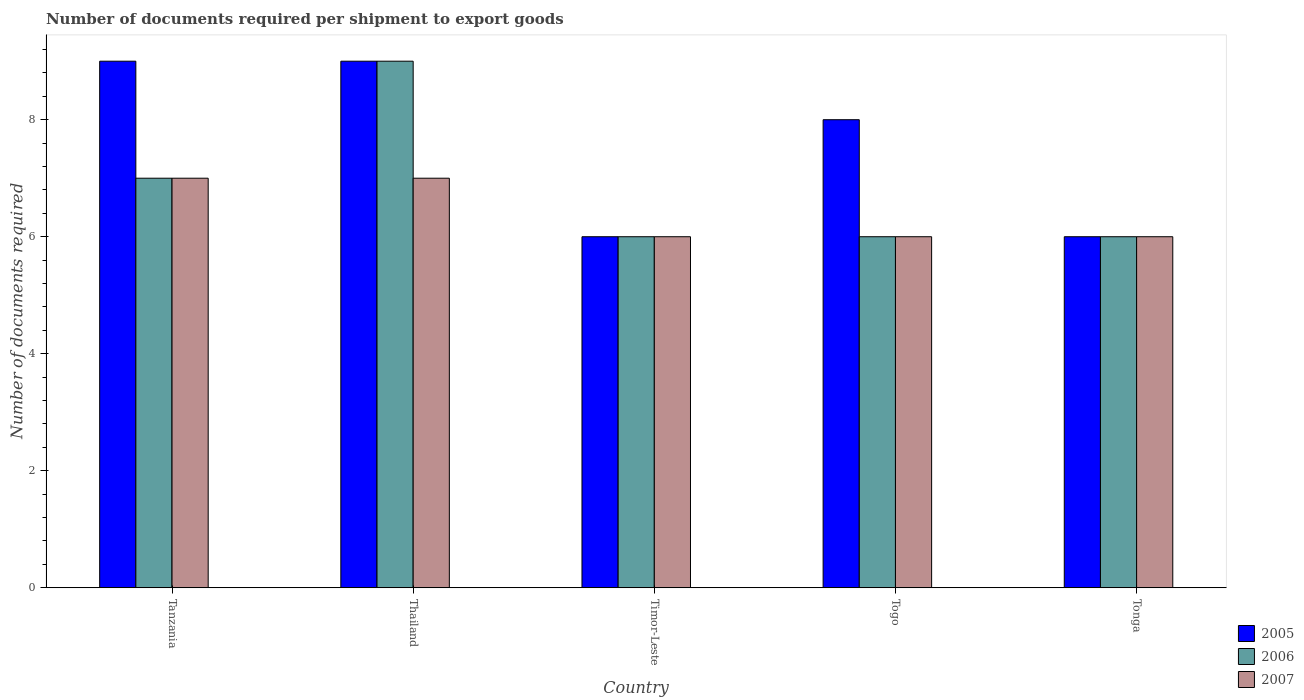Are the number of bars per tick equal to the number of legend labels?
Make the answer very short. Yes. Are the number of bars on each tick of the X-axis equal?
Provide a succinct answer. Yes. How many bars are there on the 4th tick from the left?
Your answer should be very brief. 3. How many bars are there on the 1st tick from the right?
Your answer should be very brief. 3. What is the label of the 1st group of bars from the left?
Provide a short and direct response. Tanzania. In how many cases, is the number of bars for a given country not equal to the number of legend labels?
Your response must be concise. 0. Across all countries, what is the maximum number of documents required per shipment to export goods in 2006?
Your response must be concise. 9. In which country was the number of documents required per shipment to export goods in 2007 maximum?
Ensure brevity in your answer.  Tanzania. In which country was the number of documents required per shipment to export goods in 2007 minimum?
Your answer should be compact. Timor-Leste. What is the difference between the number of documents required per shipment to export goods in 2007 in Timor-Leste and that in Togo?
Keep it short and to the point. 0. What is the difference between the number of documents required per shipment to export goods in 2005 in Togo and the number of documents required per shipment to export goods in 2007 in Thailand?
Your answer should be compact. 1. What is the average number of documents required per shipment to export goods in 2007 per country?
Offer a terse response. 6.4. In how many countries, is the number of documents required per shipment to export goods in 2005 greater than 4.4?
Offer a very short reply. 5. What is the ratio of the number of documents required per shipment to export goods in 2006 in Tanzania to that in Tonga?
Give a very brief answer. 1.17. Is the number of documents required per shipment to export goods in 2006 in Timor-Leste less than that in Togo?
Your answer should be very brief. No. What is the difference between the highest and the second highest number of documents required per shipment to export goods in 2005?
Make the answer very short. -1. In how many countries, is the number of documents required per shipment to export goods in 2007 greater than the average number of documents required per shipment to export goods in 2007 taken over all countries?
Your response must be concise. 2. Is it the case that in every country, the sum of the number of documents required per shipment to export goods in 2005 and number of documents required per shipment to export goods in 2006 is greater than the number of documents required per shipment to export goods in 2007?
Provide a succinct answer. Yes. How many bars are there?
Provide a succinct answer. 15. What is the difference between two consecutive major ticks on the Y-axis?
Your answer should be very brief. 2. Are the values on the major ticks of Y-axis written in scientific E-notation?
Ensure brevity in your answer.  No. Does the graph contain grids?
Offer a terse response. No. How many legend labels are there?
Your answer should be compact. 3. How are the legend labels stacked?
Give a very brief answer. Vertical. What is the title of the graph?
Your answer should be very brief. Number of documents required per shipment to export goods. Does "1983" appear as one of the legend labels in the graph?
Your answer should be very brief. No. What is the label or title of the X-axis?
Offer a very short reply. Country. What is the label or title of the Y-axis?
Ensure brevity in your answer.  Number of documents required. What is the Number of documents required in 2007 in Tanzania?
Your answer should be compact. 7. What is the Number of documents required of 2005 in Togo?
Ensure brevity in your answer.  8. What is the Number of documents required of 2007 in Tonga?
Ensure brevity in your answer.  6. Across all countries, what is the maximum Number of documents required in 2007?
Make the answer very short. 7. Across all countries, what is the minimum Number of documents required in 2005?
Your answer should be compact. 6. Across all countries, what is the minimum Number of documents required of 2006?
Provide a short and direct response. 6. Across all countries, what is the minimum Number of documents required of 2007?
Offer a very short reply. 6. What is the total Number of documents required in 2005 in the graph?
Ensure brevity in your answer.  38. What is the total Number of documents required of 2006 in the graph?
Ensure brevity in your answer.  34. What is the total Number of documents required in 2007 in the graph?
Ensure brevity in your answer.  32. What is the difference between the Number of documents required of 2005 in Tanzania and that in Thailand?
Provide a short and direct response. 0. What is the difference between the Number of documents required of 2006 in Tanzania and that in Timor-Leste?
Make the answer very short. 1. What is the difference between the Number of documents required of 2007 in Tanzania and that in Togo?
Give a very brief answer. 1. What is the difference between the Number of documents required of 2005 in Tanzania and that in Tonga?
Your response must be concise. 3. What is the difference between the Number of documents required in 2006 in Tanzania and that in Tonga?
Give a very brief answer. 1. What is the difference between the Number of documents required of 2005 in Thailand and that in Timor-Leste?
Provide a succinct answer. 3. What is the difference between the Number of documents required of 2007 in Thailand and that in Timor-Leste?
Offer a terse response. 1. What is the difference between the Number of documents required of 2005 in Thailand and that in Togo?
Ensure brevity in your answer.  1. What is the difference between the Number of documents required of 2005 in Thailand and that in Tonga?
Offer a terse response. 3. What is the difference between the Number of documents required of 2007 in Thailand and that in Tonga?
Keep it short and to the point. 1. What is the difference between the Number of documents required of 2005 in Timor-Leste and that in Togo?
Offer a very short reply. -2. What is the difference between the Number of documents required in 2006 in Timor-Leste and that in Togo?
Make the answer very short. 0. What is the difference between the Number of documents required in 2005 in Timor-Leste and that in Tonga?
Give a very brief answer. 0. What is the difference between the Number of documents required in 2007 in Timor-Leste and that in Tonga?
Give a very brief answer. 0. What is the difference between the Number of documents required of 2005 in Togo and that in Tonga?
Your answer should be very brief. 2. What is the difference between the Number of documents required in 2005 in Tanzania and the Number of documents required in 2007 in Thailand?
Keep it short and to the point. 2. What is the difference between the Number of documents required of 2005 in Tanzania and the Number of documents required of 2006 in Timor-Leste?
Your response must be concise. 3. What is the difference between the Number of documents required of 2006 in Tanzania and the Number of documents required of 2007 in Timor-Leste?
Keep it short and to the point. 1. What is the difference between the Number of documents required in 2006 in Tanzania and the Number of documents required in 2007 in Togo?
Make the answer very short. 1. What is the difference between the Number of documents required in 2005 in Tanzania and the Number of documents required in 2006 in Tonga?
Give a very brief answer. 3. What is the difference between the Number of documents required of 2005 in Thailand and the Number of documents required of 2006 in Timor-Leste?
Ensure brevity in your answer.  3. What is the difference between the Number of documents required in 2006 in Thailand and the Number of documents required in 2007 in Timor-Leste?
Offer a terse response. 3. What is the difference between the Number of documents required of 2005 in Thailand and the Number of documents required of 2006 in Tonga?
Provide a succinct answer. 3. What is the difference between the Number of documents required in 2005 in Thailand and the Number of documents required in 2007 in Tonga?
Ensure brevity in your answer.  3. What is the difference between the Number of documents required in 2006 in Thailand and the Number of documents required in 2007 in Tonga?
Your answer should be compact. 3. What is the difference between the Number of documents required of 2006 in Timor-Leste and the Number of documents required of 2007 in Tonga?
Your response must be concise. 0. What is the difference between the Number of documents required in 2005 in Togo and the Number of documents required in 2007 in Tonga?
Offer a terse response. 2. What is the average Number of documents required in 2005 per country?
Offer a terse response. 7.6. What is the average Number of documents required of 2007 per country?
Make the answer very short. 6.4. What is the difference between the Number of documents required in 2006 and Number of documents required in 2007 in Tanzania?
Keep it short and to the point. 0. What is the difference between the Number of documents required in 2006 and Number of documents required in 2007 in Timor-Leste?
Give a very brief answer. 0. What is the difference between the Number of documents required of 2005 and Number of documents required of 2007 in Togo?
Offer a very short reply. 2. What is the difference between the Number of documents required of 2005 and Number of documents required of 2006 in Tonga?
Your answer should be compact. 0. What is the difference between the Number of documents required of 2005 and Number of documents required of 2007 in Tonga?
Offer a terse response. 0. What is the difference between the Number of documents required of 2006 and Number of documents required of 2007 in Tonga?
Give a very brief answer. 0. What is the ratio of the Number of documents required in 2007 in Tanzania to that in Thailand?
Offer a very short reply. 1. What is the ratio of the Number of documents required in 2005 in Tanzania to that in Timor-Leste?
Make the answer very short. 1.5. What is the ratio of the Number of documents required in 2007 in Tanzania to that in Timor-Leste?
Give a very brief answer. 1.17. What is the ratio of the Number of documents required in 2005 in Tanzania to that in Togo?
Your response must be concise. 1.12. What is the ratio of the Number of documents required of 2006 in Tanzania to that in Togo?
Provide a short and direct response. 1.17. What is the ratio of the Number of documents required of 2007 in Tanzania to that in Togo?
Offer a very short reply. 1.17. What is the ratio of the Number of documents required in 2007 in Tanzania to that in Tonga?
Your response must be concise. 1.17. What is the ratio of the Number of documents required in 2006 in Thailand to that in Timor-Leste?
Offer a terse response. 1.5. What is the ratio of the Number of documents required of 2006 in Thailand to that in Togo?
Keep it short and to the point. 1.5. What is the ratio of the Number of documents required of 2007 in Thailand to that in Togo?
Provide a succinct answer. 1.17. What is the ratio of the Number of documents required of 2005 in Thailand to that in Tonga?
Your answer should be very brief. 1.5. What is the ratio of the Number of documents required in 2005 in Timor-Leste to that in Togo?
Your answer should be very brief. 0.75. What is the ratio of the Number of documents required in 2005 in Timor-Leste to that in Tonga?
Your answer should be compact. 1. What is the ratio of the Number of documents required in 2005 in Togo to that in Tonga?
Offer a very short reply. 1.33. What is the difference between the highest and the second highest Number of documents required of 2006?
Give a very brief answer. 2. What is the difference between the highest and the second highest Number of documents required of 2007?
Make the answer very short. 0. What is the difference between the highest and the lowest Number of documents required of 2006?
Offer a terse response. 3. 